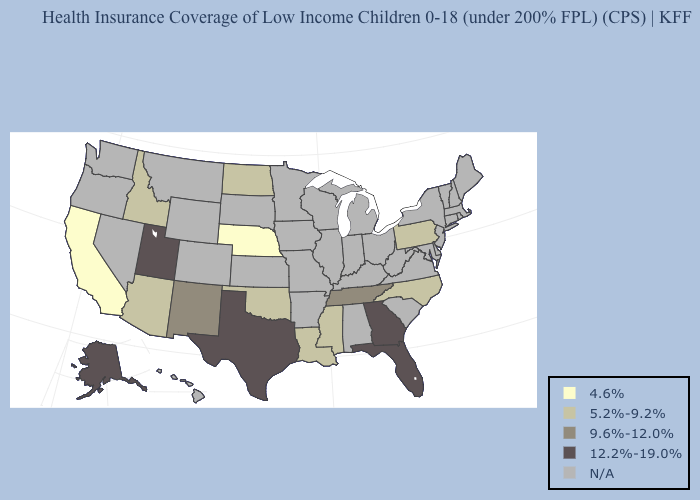Does California have the highest value in the West?
Concise answer only. No. Name the states that have a value in the range N/A?
Keep it brief. Alabama, Arkansas, Colorado, Connecticut, Delaware, Hawaii, Illinois, Indiana, Iowa, Kansas, Kentucky, Maine, Maryland, Massachusetts, Michigan, Minnesota, Missouri, Montana, Nevada, New Hampshire, New Jersey, New York, Ohio, Oregon, Rhode Island, South Carolina, South Dakota, Vermont, Virginia, Washington, West Virginia, Wisconsin, Wyoming. Which states have the lowest value in the USA?
Give a very brief answer. California, Nebraska. Name the states that have a value in the range 12.2%-19.0%?
Short answer required. Alaska, Florida, Georgia, Texas, Utah. Name the states that have a value in the range 9.6%-12.0%?
Concise answer only. New Mexico, Tennessee. Does the first symbol in the legend represent the smallest category?
Be succinct. Yes. Among the states that border Arizona , which have the lowest value?
Be succinct. California. Which states have the highest value in the USA?
Keep it brief. Alaska, Florida, Georgia, Texas, Utah. Name the states that have a value in the range N/A?
Quick response, please. Alabama, Arkansas, Colorado, Connecticut, Delaware, Hawaii, Illinois, Indiana, Iowa, Kansas, Kentucky, Maine, Maryland, Massachusetts, Michigan, Minnesota, Missouri, Montana, Nevada, New Hampshire, New Jersey, New York, Ohio, Oregon, Rhode Island, South Carolina, South Dakota, Vermont, Virginia, Washington, West Virginia, Wisconsin, Wyoming. What is the value of Massachusetts?
Be succinct. N/A. Name the states that have a value in the range 5.2%-9.2%?
Give a very brief answer. Arizona, Idaho, Louisiana, Mississippi, North Carolina, North Dakota, Oklahoma, Pennsylvania. What is the lowest value in the USA?
Quick response, please. 4.6%. What is the value of Maryland?
Quick response, please. N/A. What is the value of Kansas?
Short answer required. N/A. 